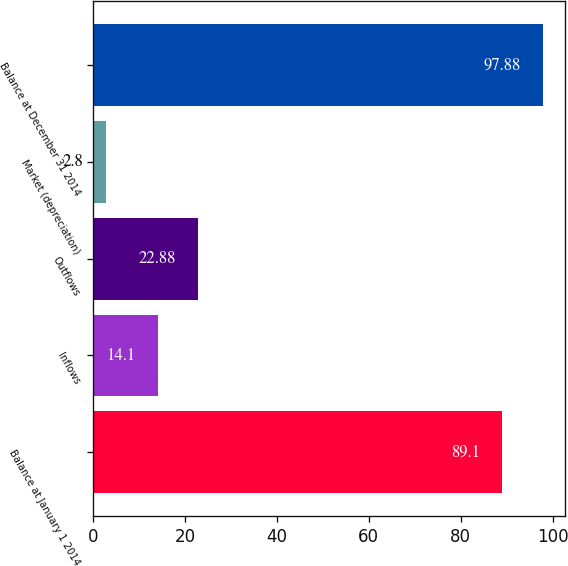Convert chart. <chart><loc_0><loc_0><loc_500><loc_500><bar_chart><fcel>Balance at January 1 2014<fcel>Inflows<fcel>Outflows<fcel>Market (depreciation)<fcel>Balance at December 31 2014<nl><fcel>89.1<fcel>14.1<fcel>22.88<fcel>2.8<fcel>97.88<nl></chart> 